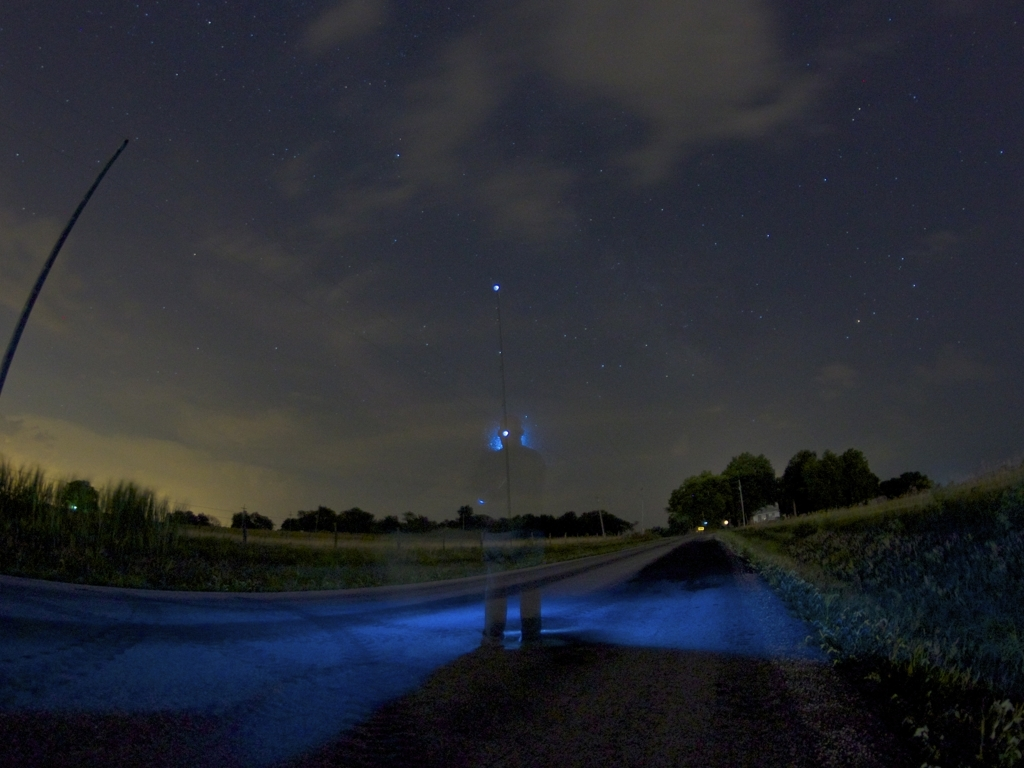How would you rate the quality of this image? The image has an intriguing composition featuring starry skies and an ethereal figure created by a long exposure, which can be artistically appreciated. However, technically, it's slightly grainy and not particularly well-focused, which might be intentional to achieve a certain effect, but overall, it might be considered of moderate quality. 